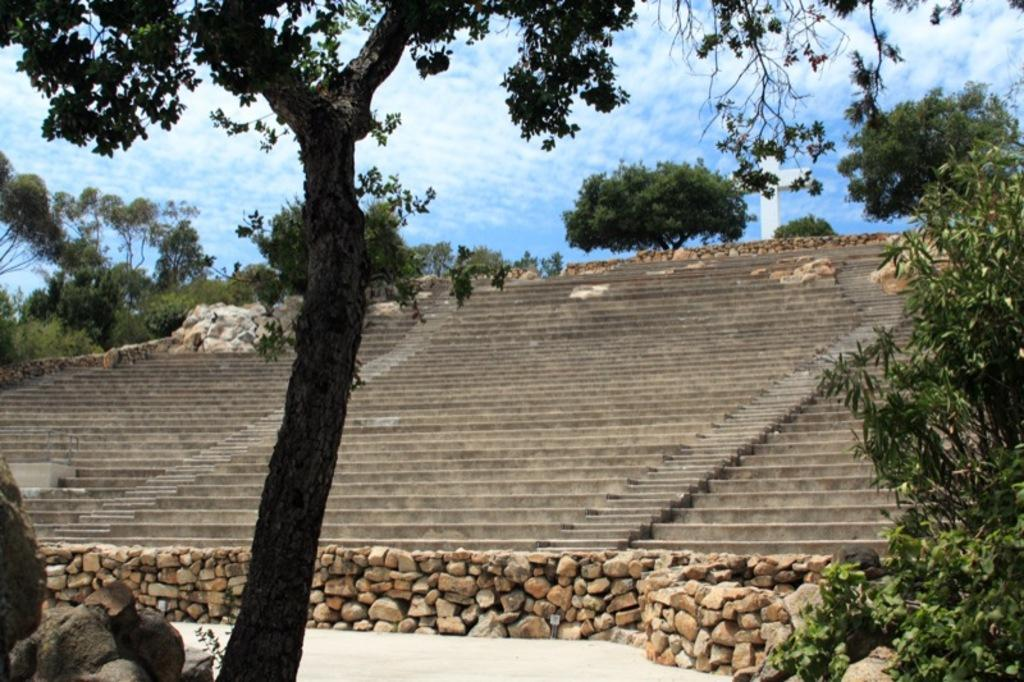What type of natural elements can be seen in the image? There are trees and rocks in the image. What man-made structure is present in the image? There are stairs in the image. What can be seen in the background of the image? In the background, there are many trees, a cross symbol, clouds, and the sky. What type of toothpaste is being advertised in the image? There is no toothpaste or advertisement present in the image. What song is being played in the background of the image? There is no music or song playing in the image. 